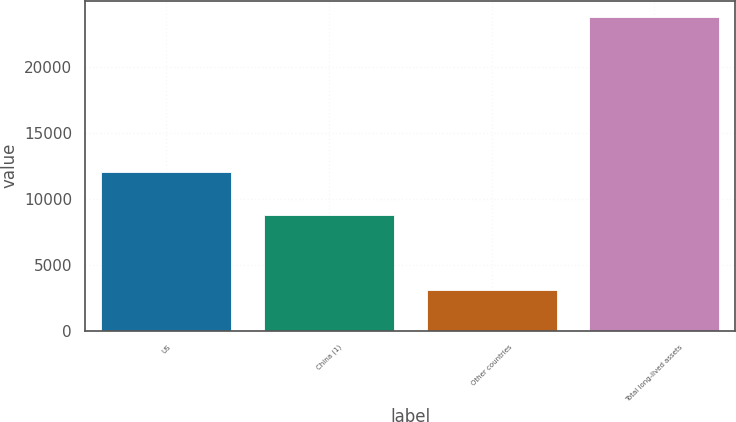Convert chart. <chart><loc_0><loc_0><loc_500><loc_500><bar_chart><fcel>US<fcel>China (1)<fcel>Other countries<fcel>Total long-lived assets<nl><fcel>12022<fcel>8722<fcel>3040<fcel>23784<nl></chart> 